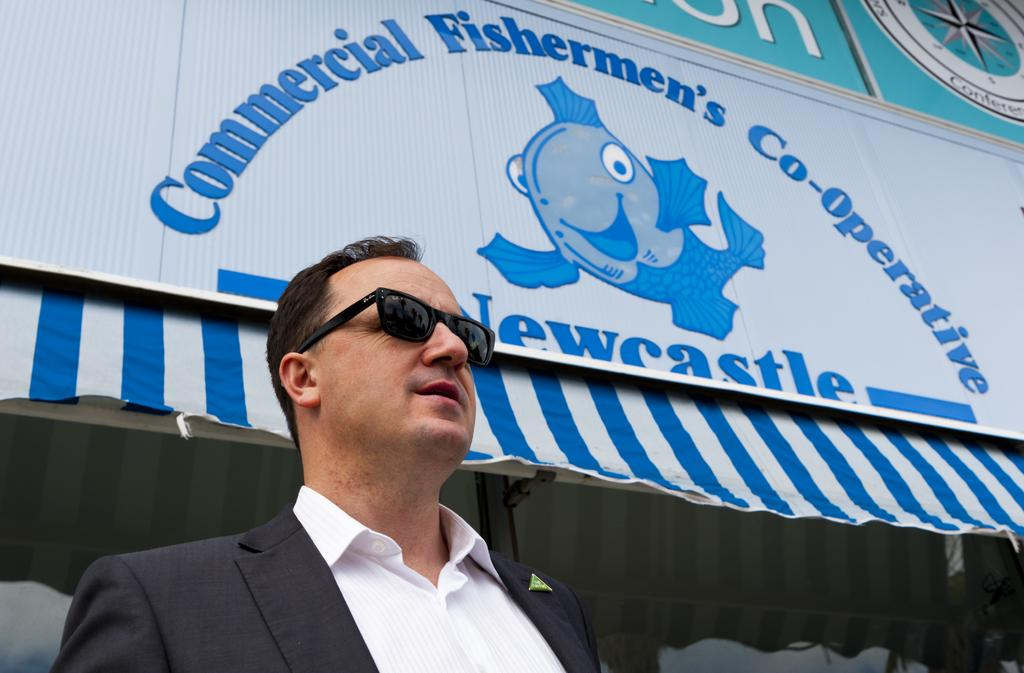What is present in the image? There is a man and an advertisement on a tent in the image. Can you describe the advertisement in the image? The advertisement is on a tent in the image. How many women are performing with the band in the image? There is no band or women present in the image; it only features a man and an advertisement on a tent. 